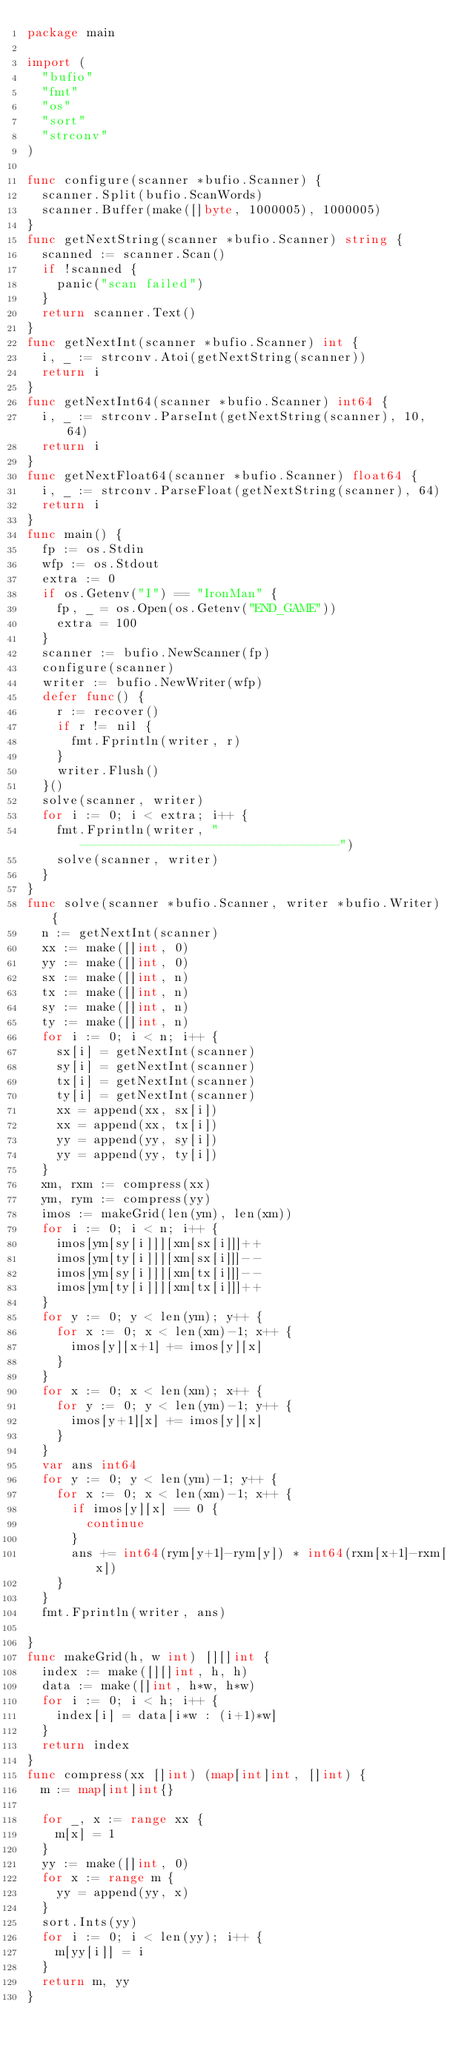<code> <loc_0><loc_0><loc_500><loc_500><_Go_>package main

import (
	"bufio"
	"fmt"
	"os"
	"sort"
	"strconv"
)

func configure(scanner *bufio.Scanner) {
	scanner.Split(bufio.ScanWords)
	scanner.Buffer(make([]byte, 1000005), 1000005)
}
func getNextString(scanner *bufio.Scanner) string {
	scanned := scanner.Scan()
	if !scanned {
		panic("scan failed")
	}
	return scanner.Text()
}
func getNextInt(scanner *bufio.Scanner) int {
	i, _ := strconv.Atoi(getNextString(scanner))
	return i
}
func getNextInt64(scanner *bufio.Scanner) int64 {
	i, _ := strconv.ParseInt(getNextString(scanner), 10, 64)
	return i
}
func getNextFloat64(scanner *bufio.Scanner) float64 {
	i, _ := strconv.ParseFloat(getNextString(scanner), 64)
	return i
}
func main() {
	fp := os.Stdin
	wfp := os.Stdout
	extra := 0
	if os.Getenv("I") == "IronMan" {
		fp, _ = os.Open(os.Getenv("END_GAME"))
		extra = 100
	}
	scanner := bufio.NewScanner(fp)
	configure(scanner)
	writer := bufio.NewWriter(wfp)
	defer func() {
		r := recover()
		if r != nil {
			fmt.Fprintln(writer, r)
		}
		writer.Flush()
	}()
	solve(scanner, writer)
	for i := 0; i < extra; i++ {
		fmt.Fprintln(writer, "-----------------------------------")
		solve(scanner, writer)
	}
}
func solve(scanner *bufio.Scanner, writer *bufio.Writer) {
	n := getNextInt(scanner)
	xx := make([]int, 0)
	yy := make([]int, 0)
	sx := make([]int, n)
	tx := make([]int, n)
	sy := make([]int, n)
	ty := make([]int, n)
	for i := 0; i < n; i++ {
		sx[i] = getNextInt(scanner)
		sy[i] = getNextInt(scanner)
		tx[i] = getNextInt(scanner)
		ty[i] = getNextInt(scanner)
		xx = append(xx, sx[i])
		xx = append(xx, tx[i])
		yy = append(yy, sy[i])
		yy = append(yy, ty[i])
	}
	xm, rxm := compress(xx)
	ym, rym := compress(yy)
	imos := makeGrid(len(ym), len(xm))
	for i := 0; i < n; i++ {
		imos[ym[sy[i]]][xm[sx[i]]]++
		imos[ym[ty[i]]][xm[sx[i]]]--
		imos[ym[sy[i]]][xm[tx[i]]]--
		imos[ym[ty[i]]][xm[tx[i]]]++
	}
	for y := 0; y < len(ym); y++ {
		for x := 0; x < len(xm)-1; x++ {
			imos[y][x+1] += imos[y][x]
		}
	}
	for x := 0; x < len(xm); x++ {
		for y := 0; y < len(ym)-1; y++ {
			imos[y+1][x] += imos[y][x]
		}
	}
	var ans int64
	for y := 0; y < len(ym)-1; y++ {
		for x := 0; x < len(xm)-1; x++ {
			if imos[y][x] == 0 {
				continue
			}
			ans += int64(rym[y+1]-rym[y]) * int64(rxm[x+1]-rxm[x])
		}
	}
	fmt.Fprintln(writer, ans)

}
func makeGrid(h, w int) [][]int {
	index := make([][]int, h, h)
	data := make([]int, h*w, h*w)
	for i := 0; i < h; i++ {
		index[i] = data[i*w : (i+1)*w]
	}
	return index
}
func compress(xx []int) (map[int]int, []int) {
	m := map[int]int{}

	for _, x := range xx {
		m[x] = 1
	}
	yy := make([]int, 0)
	for x := range m {
		yy = append(yy, x)
	}
	sort.Ints(yy)
	for i := 0; i < len(yy); i++ {
		m[yy[i]] = i
	}
	return m, yy
}

</code> 